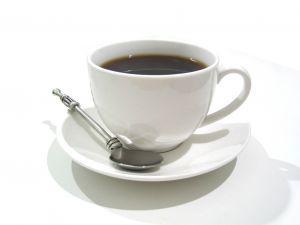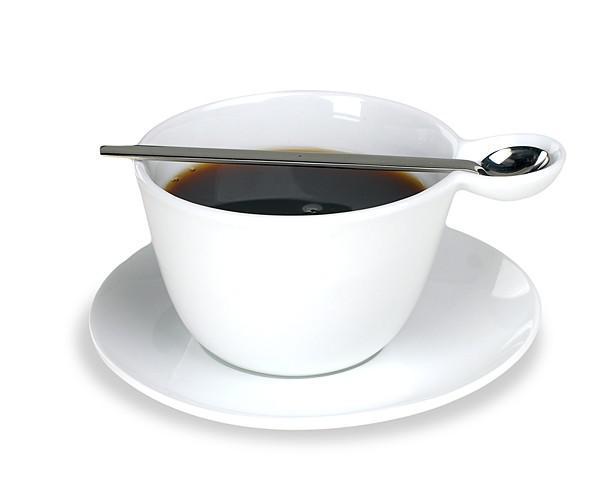The first image is the image on the left, the second image is the image on the right. For the images displayed, is the sentence "The handle of a utensil sticks out of a cup of coffee in at least one image." factually correct? Answer yes or no. No. The first image is the image on the left, the second image is the image on the right. For the images shown, is this caption "There is a spoon in at least one teacup" true? Answer yes or no. No. 